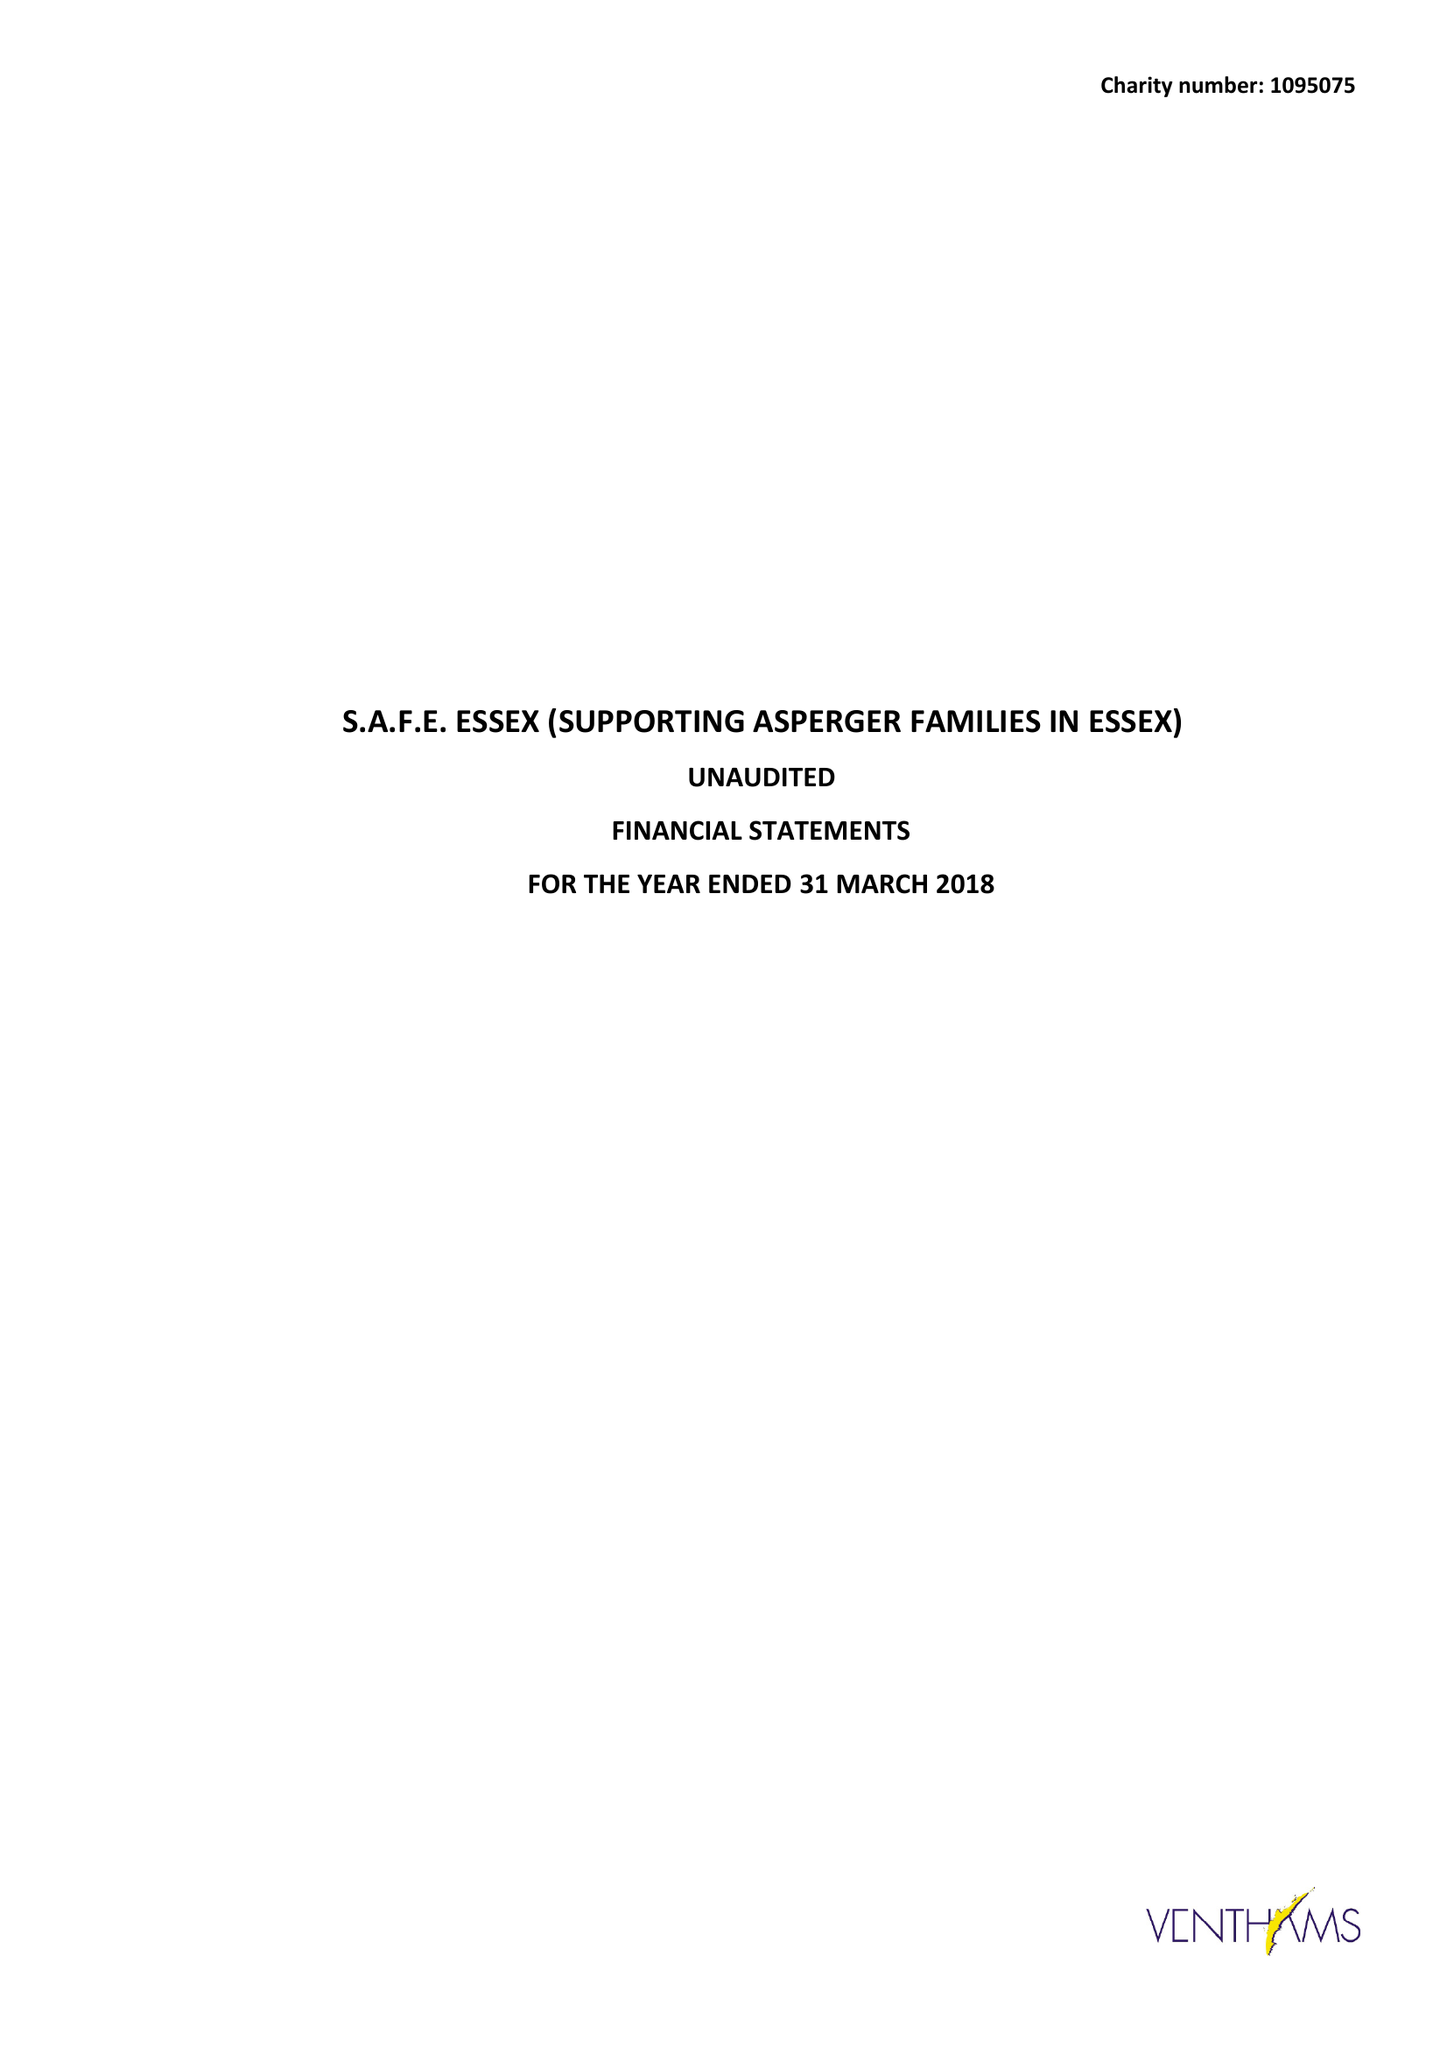What is the value for the address__postcode?
Answer the question using a single word or phrase. CM8 3PD 